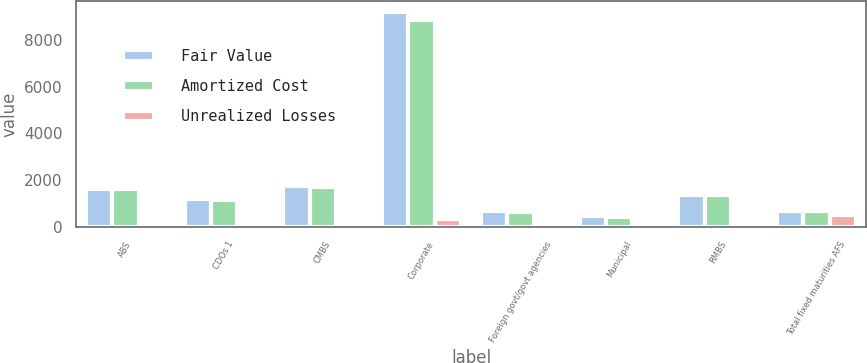<chart> <loc_0><loc_0><loc_500><loc_500><stacked_bar_chart><ecel><fcel>ABS<fcel>CDOs 1<fcel>CMBS<fcel>Corporate<fcel>Foreign govt/govt agencies<fcel>Municipal<fcel>RMBS<fcel>Total fixed maturities AFS<nl><fcel>Fair Value<fcel>1619<fcel>1164<fcel>1726<fcel>9206<fcel>679<fcel>440<fcel>1349<fcel>662.5<nl><fcel>Amortized Cost<fcel>1609<fcel>1154<fcel>1681<fcel>8866<fcel>646<fcel>430<fcel>1340<fcel>662.5<nl><fcel>Unrealized Losses<fcel>10<fcel>10<fcel>45<fcel>340<fcel>33<fcel>10<fcel>9<fcel>495<nl></chart> 